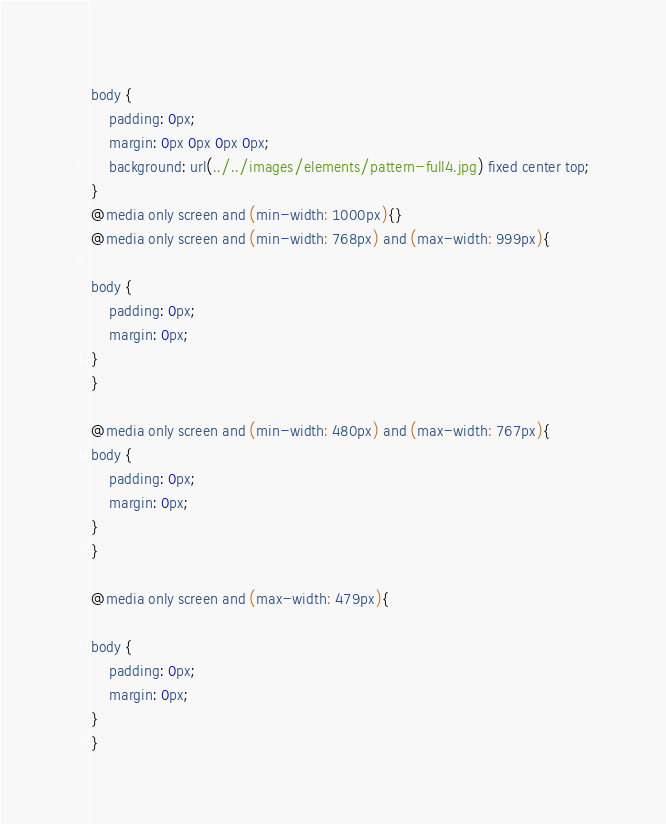Convert code to text. <code><loc_0><loc_0><loc_500><loc_500><_CSS_>body {
	padding: 0px;
	margin: 0px 0px 0px 0px;
	background: url(../../images/elements/pattern-full4.jpg) fixed center top;
}
@media only screen and (min-width: 1000px){}
@media only screen and (min-width: 768px) and (max-width: 999px){

body {
	padding: 0px;
	margin: 0px;
}
}

@media only screen and (min-width: 480px) and (max-width: 767px){
body {
	padding: 0px;
	margin: 0px;
}
}

@media only screen and (max-width: 479px){

body {
	padding: 0px;
	margin: 0px;
}
}</code> 